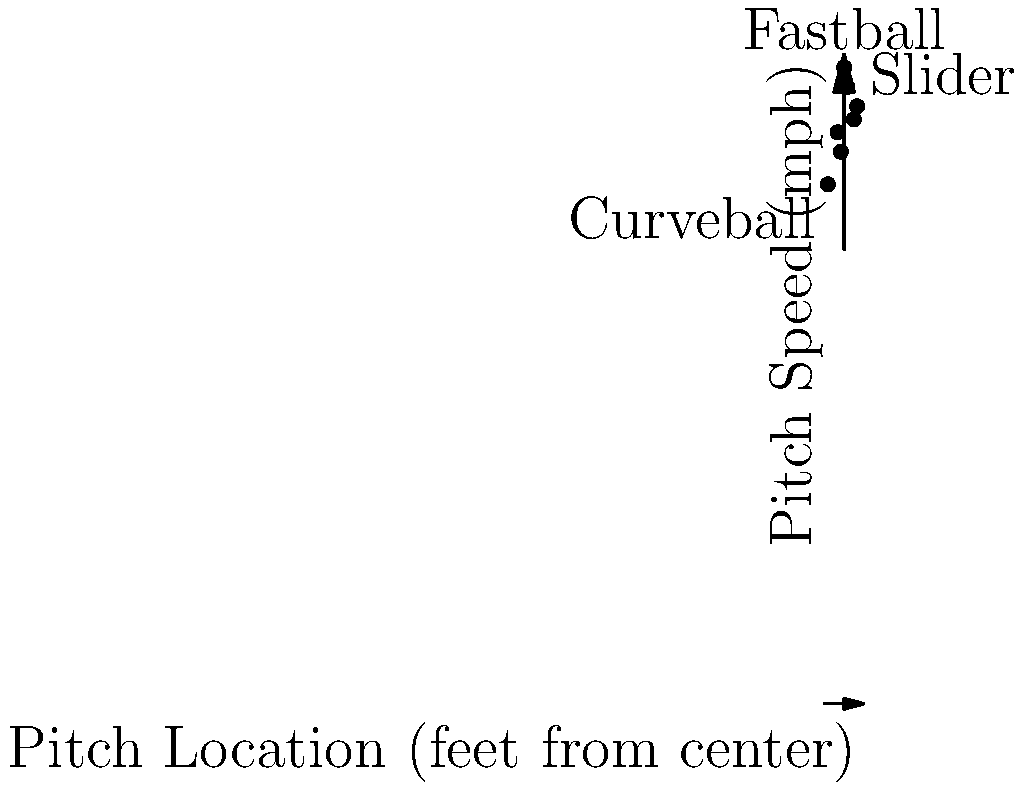Based on the scatter plot of pitch speeds versus pitch locations, which type of pitch is typically thrown with the highest velocity and closest to the center of the strike zone? To answer this question, we need to analyze the scatter plot:

1. First, identify the axes:
   - X-axis represents pitch location (feet from center)
   - Y-axis represents pitch speed (mph)

2. Look for the point with the highest y-value (speed) and an x-value close to 0 (center of the strike zone):
   - The point at (0, 98) has the highest y-value and is exactly at the center.
   - This point is labeled "Fastball"

3. Compare this to other labeled pitches:
   - "Curveball" is at (-2.5, 80), which is slower and further from the center.
   - "Slider" is at (2, 92), which is faster than the curveball but slower than the fastball and further from the center.

4. Conclude that the fastball is typically thrown with the highest velocity and closest to the center of the strike zone.

This aligns with common baseball knowledge: fastballs are generally the fastest pitches and are often aimed at the heart of the strike zone.
Answer: Fastball 